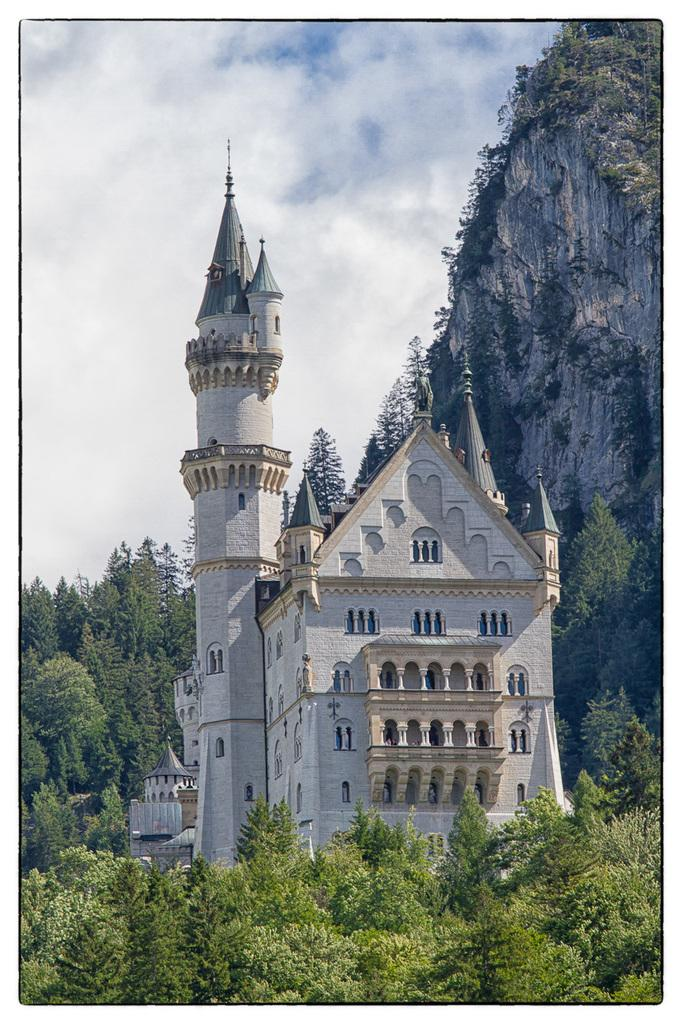What type of vegetation is at the bottom of the image? There are trees at the bottom of the image. What type of structure can be seen in the background of the image? There is a building in the background of the image. What feature of the building is visible in the image? There are windows visible in the background of the image. What else can be seen in the background of the image besides the building? There are trees and clouds in the sky in the background of the image. What geographical feature is on the right side of the image? There is a mountain on the right side of the image. What type of cloud is being copied in the image? There is no cloud being copied in the image; the clouds are natural formations in the sky. How does the comparison between the trees and the building affect the overall composition of the image? The question assumes a comparison that is not present in the image, as the facts provided do not mention any comparison between the trees and the building. 